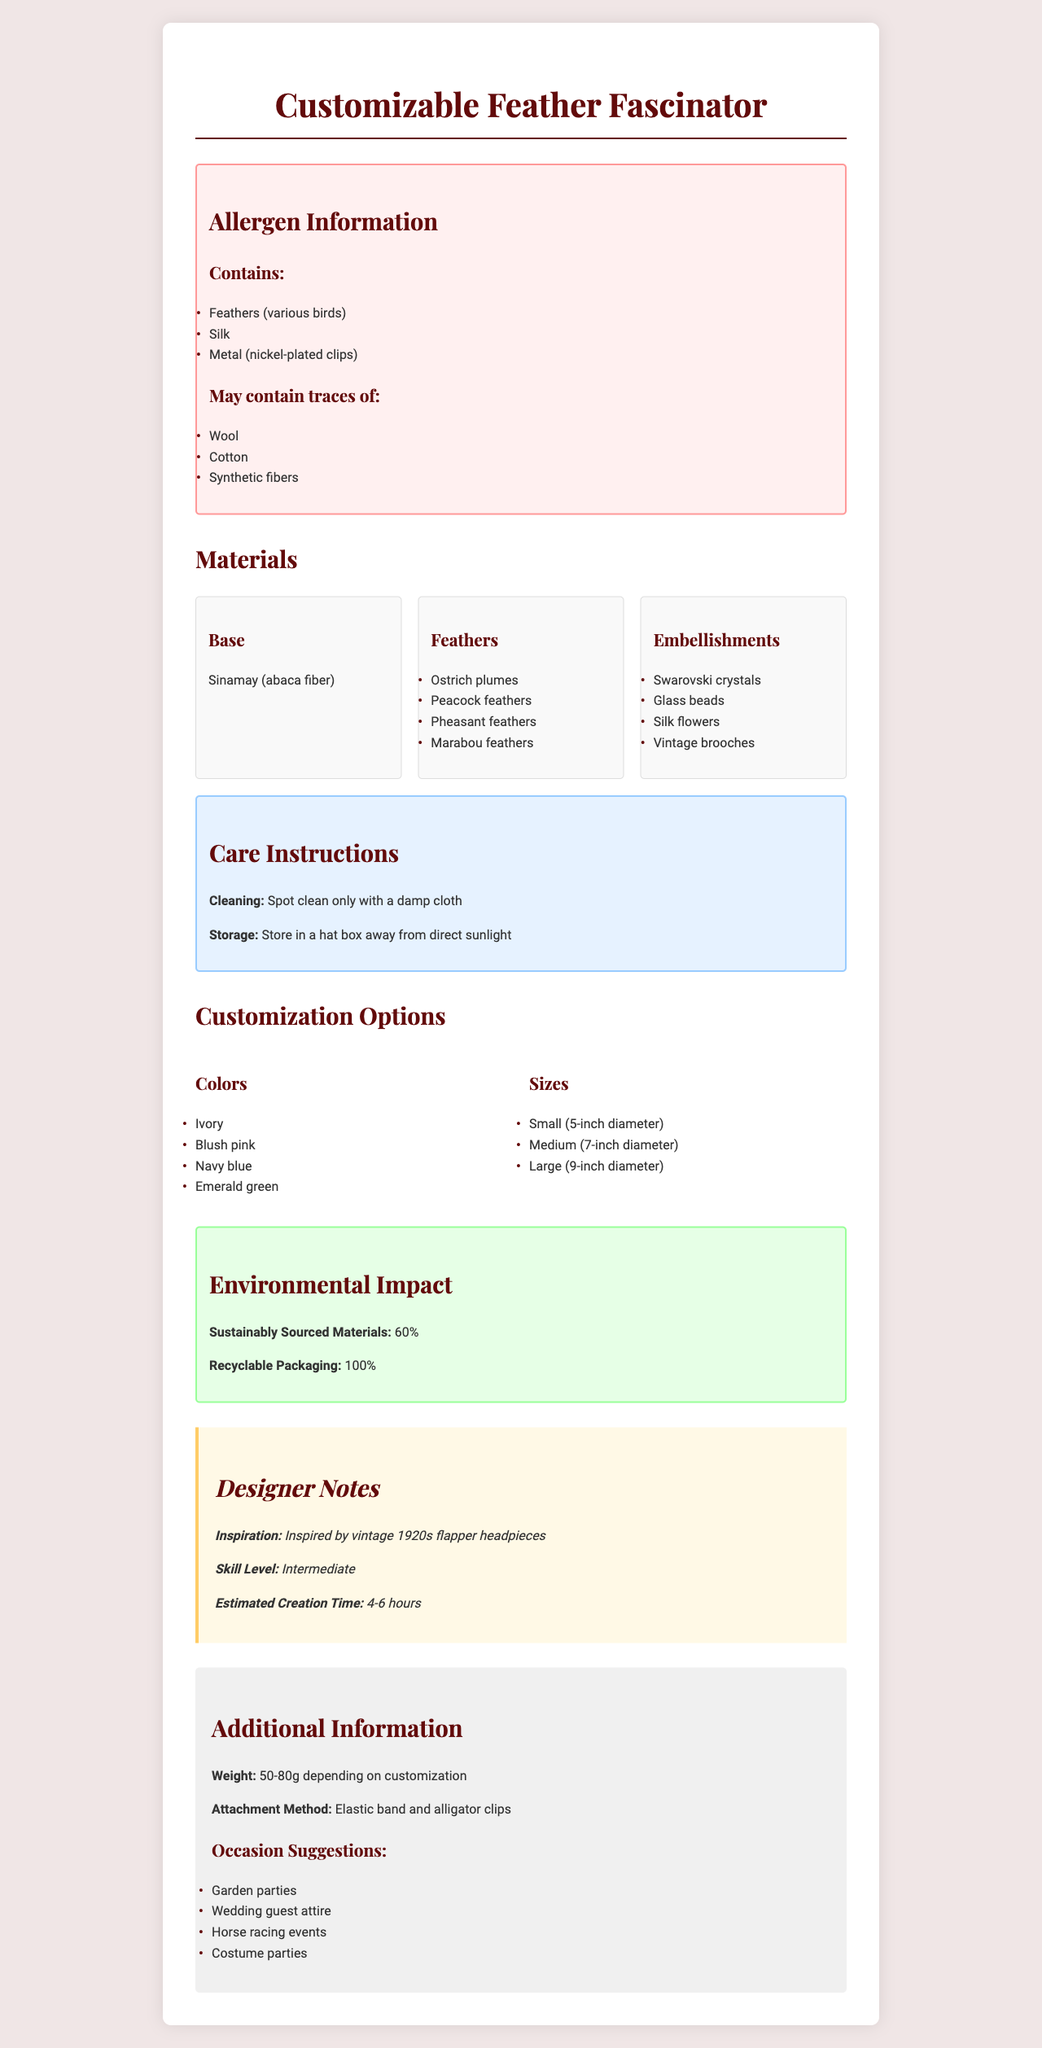What are the main allergens in the Customizable Feather Fascinator? The allergen information section lists Feathers (various birds), Silk, Metal (nickel-plated clips) as the main allergens.
Answer: Feathers (various birds), Silk, Metal (nickel-plated clips) Does the fascinator contain wool? According to the allergen information, it does not directly contain wool but may contain traces of it.
Answer: It may contain traces of wool. What materials are used for the base of the fascinator? The materials section specifies Sinamay (abaca fiber) as the material used for the base.
Answer: Sinamay (abaca fiber) Which feathers are used in the fascinator? The materials section lists Ostrich plumes, Peacock feathers, Pheasant feathers, and Marabou feathers as the feathers used.
Answer: Ostrich plumes, Peacock feathers, Pheasant feathers, Marabou feathers What are the customization color options? The customization options section provides the colors Ivory, Blush pink, Navy blue, and Emerald green as options.
Answer: Ivory, Blush pink, Navy blue, Emerald green Which of the following is NOT listed as an embellishment option? A. Swarovski crystals B. Leather patches C. Silk flowers D. Glass beads Leather patches are not listed as an embellishment option in the materials section.
Answer: B. Leather patches How should you clean the fascinator? The care instructions indicate that you should spot clean it only with a damp cloth.
Answer: Spot clean only with a damp cloth Is the fascinator packaged in recyclable materials? The environmental impact section states that the packaging is 100% recyclable.
Answer: Yes How long does it estimate to create the Customizable Feather Fascinator? The designer notes section mentions that the estimated creation time is 4-6 hours.
Answer: 4-6 hours What occasions are suggested for wearing the fascinator? The additional information section lists these occasions as suggestions for wearing the fascinator.
Answer: Garden parties, Wedding guest attire, Horse racing events, Costume parties What percentage of the materials are sustainably sourced? A. 30% B. 50% C. 60% D. 80% The environmental impact section states that 60% of the materials are sustainably sourced.
Answer: C. 60% Is the fascinator suitable for beginners to make? The designer notes section indicates that the skill level required is intermediate.
Answer: No Summarize the main information provided about the product. The document provides comprehensive information on the materials, customization options, care instructions, allergen details, environmental impact, and usage suggestions for the fascinator.
Answer: The Customizable Feather Fascinator is a decorative headpiece made from various feathers and embellishments such as Swarovski crystals, glass beads, and silk flowers. It offers customization options in colors and sizes and is made with 60% sustainably sourced materials. The product is for intermediate skill levels, and the estimated creation time is 4-6 hours. Allergen information includes feathers (various birds), silk, and metal (nickel-plated clips), with potential traces of wool, cotton, and synthetic fibers. Care instructions emphasize spot cleaning and proper storage to maintain condition. What is the warranty period for the fascinator? The document does not provide any information about the warranty period for the fascinator.
Answer: Cannot be determined 